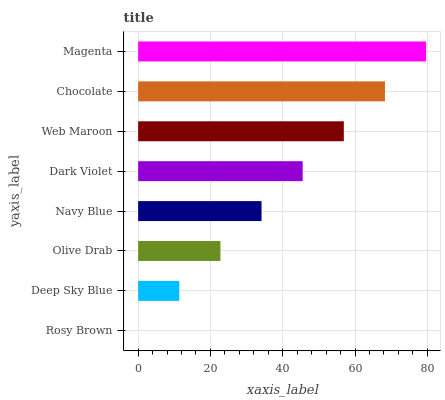Is Rosy Brown the minimum?
Answer yes or no. Yes. Is Magenta the maximum?
Answer yes or no. Yes. Is Deep Sky Blue the minimum?
Answer yes or no. No. Is Deep Sky Blue the maximum?
Answer yes or no. No. Is Deep Sky Blue greater than Rosy Brown?
Answer yes or no. Yes. Is Rosy Brown less than Deep Sky Blue?
Answer yes or no. Yes. Is Rosy Brown greater than Deep Sky Blue?
Answer yes or no. No. Is Deep Sky Blue less than Rosy Brown?
Answer yes or no. No. Is Dark Violet the high median?
Answer yes or no. Yes. Is Navy Blue the low median?
Answer yes or no. Yes. Is Olive Drab the high median?
Answer yes or no. No. Is Deep Sky Blue the low median?
Answer yes or no. No. 